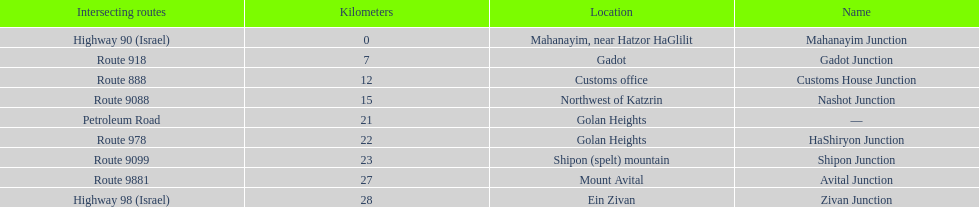Which junctions cross a route? Gadot Junction, Customs House Junction, Nashot Junction, HaShiryon Junction, Shipon Junction, Avital Junction. Which of these shares [art of its name with its locations name? Gadot Junction, Customs House Junction, Shipon Junction, Avital Junction. Which of them is not located in a locations named after a mountain? Gadot Junction, Customs House Junction. Which of these has the highest route number? Gadot Junction. 